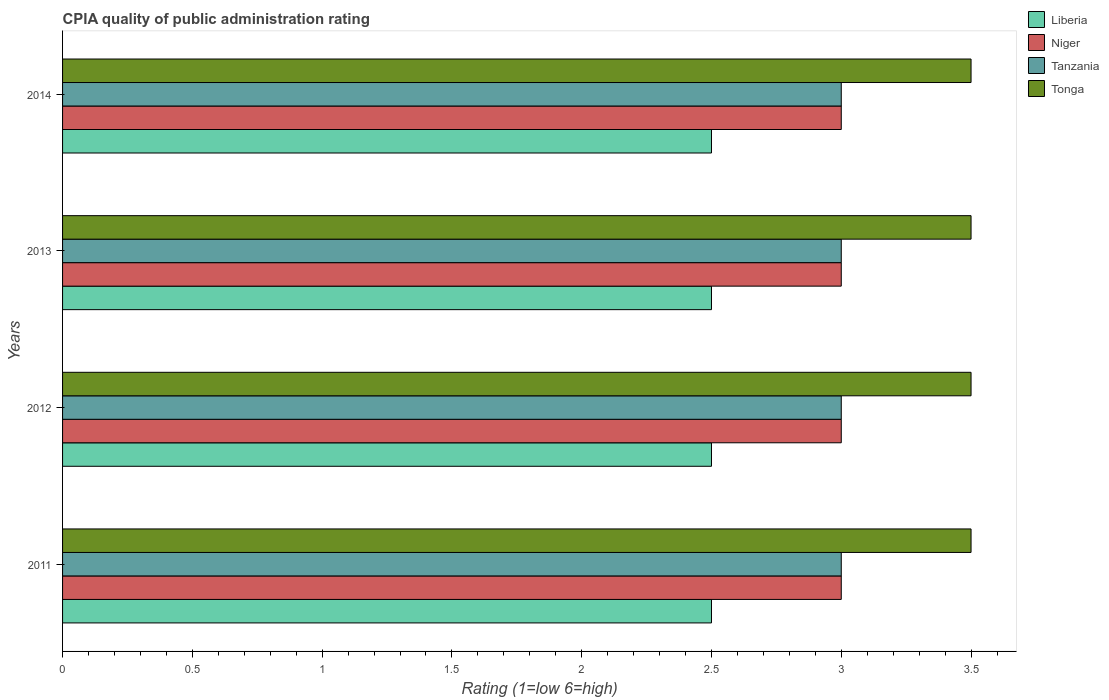Are the number of bars per tick equal to the number of legend labels?
Your answer should be compact. Yes. Are the number of bars on each tick of the Y-axis equal?
Ensure brevity in your answer.  Yes. How many bars are there on the 2nd tick from the bottom?
Ensure brevity in your answer.  4. What is the label of the 4th group of bars from the top?
Make the answer very short. 2011. In how many cases, is the number of bars for a given year not equal to the number of legend labels?
Your answer should be compact. 0. What is the CPIA rating in Niger in 2013?
Make the answer very short. 3. Across all years, what is the maximum CPIA rating in Niger?
Give a very brief answer. 3. Across all years, what is the minimum CPIA rating in Niger?
Ensure brevity in your answer.  3. In which year was the CPIA rating in Tonga maximum?
Keep it short and to the point. 2011. What is the total CPIA rating in Tonga in the graph?
Ensure brevity in your answer.  14. What is the difference between the CPIA rating in Tonga in 2011 and that in 2013?
Offer a terse response. 0. In the year 2013, what is the difference between the CPIA rating in Niger and CPIA rating in Liberia?
Give a very brief answer. 0.5. In how many years, is the CPIA rating in Liberia greater than 1.6 ?
Provide a short and direct response. 4. Is the difference between the CPIA rating in Niger in 2011 and 2014 greater than the difference between the CPIA rating in Liberia in 2011 and 2014?
Make the answer very short. No. What is the difference between the highest and the second highest CPIA rating in Tanzania?
Your response must be concise. 0. In how many years, is the CPIA rating in Niger greater than the average CPIA rating in Niger taken over all years?
Give a very brief answer. 0. Is the sum of the CPIA rating in Tanzania in 2011 and 2014 greater than the maximum CPIA rating in Tonga across all years?
Offer a very short reply. Yes. Is it the case that in every year, the sum of the CPIA rating in Liberia and CPIA rating in Tanzania is greater than the sum of CPIA rating in Tonga and CPIA rating in Niger?
Make the answer very short. Yes. What does the 2nd bar from the top in 2014 represents?
Your answer should be compact. Tanzania. What does the 2nd bar from the bottom in 2012 represents?
Keep it short and to the point. Niger. How many years are there in the graph?
Your answer should be compact. 4. What is the difference between two consecutive major ticks on the X-axis?
Ensure brevity in your answer.  0.5. What is the title of the graph?
Make the answer very short. CPIA quality of public administration rating. Does "Chile" appear as one of the legend labels in the graph?
Provide a succinct answer. No. What is the label or title of the X-axis?
Your response must be concise. Rating (1=low 6=high). What is the label or title of the Y-axis?
Your answer should be compact. Years. What is the Rating (1=low 6=high) of Liberia in 2011?
Ensure brevity in your answer.  2.5. What is the Rating (1=low 6=high) of Tanzania in 2011?
Your answer should be compact. 3. What is the Rating (1=low 6=high) of Tonga in 2011?
Give a very brief answer. 3.5. What is the Rating (1=low 6=high) in Liberia in 2012?
Give a very brief answer. 2.5. What is the Rating (1=low 6=high) in Niger in 2012?
Your response must be concise. 3. What is the Rating (1=low 6=high) in Niger in 2013?
Offer a very short reply. 3. What is the Rating (1=low 6=high) in Tonga in 2013?
Your answer should be very brief. 3.5. What is the Rating (1=low 6=high) in Liberia in 2014?
Give a very brief answer. 2.5. What is the Rating (1=low 6=high) in Tonga in 2014?
Provide a short and direct response. 3.5. Across all years, what is the maximum Rating (1=low 6=high) in Tanzania?
Provide a short and direct response. 3. Across all years, what is the minimum Rating (1=low 6=high) in Liberia?
Your answer should be very brief. 2.5. Across all years, what is the minimum Rating (1=low 6=high) in Tanzania?
Your answer should be compact. 3. What is the total Rating (1=low 6=high) of Liberia in the graph?
Provide a succinct answer. 10. What is the total Rating (1=low 6=high) of Tanzania in the graph?
Keep it short and to the point. 12. What is the difference between the Rating (1=low 6=high) in Liberia in 2011 and that in 2012?
Provide a succinct answer. 0. What is the difference between the Rating (1=low 6=high) of Tanzania in 2011 and that in 2012?
Give a very brief answer. 0. What is the difference between the Rating (1=low 6=high) in Tonga in 2011 and that in 2012?
Provide a short and direct response. 0. What is the difference between the Rating (1=low 6=high) in Niger in 2011 and that in 2013?
Give a very brief answer. 0. What is the difference between the Rating (1=low 6=high) of Tanzania in 2011 and that in 2013?
Your answer should be very brief. 0. What is the difference between the Rating (1=low 6=high) of Liberia in 2011 and that in 2014?
Provide a short and direct response. 0. What is the difference between the Rating (1=low 6=high) in Niger in 2011 and that in 2014?
Provide a short and direct response. 0. What is the difference between the Rating (1=low 6=high) in Tonga in 2011 and that in 2014?
Keep it short and to the point. 0. What is the difference between the Rating (1=low 6=high) in Tanzania in 2012 and that in 2013?
Provide a succinct answer. 0. What is the difference between the Rating (1=low 6=high) of Tonga in 2012 and that in 2013?
Offer a terse response. 0. What is the difference between the Rating (1=low 6=high) of Liberia in 2012 and that in 2014?
Offer a very short reply. 0. What is the difference between the Rating (1=low 6=high) of Tanzania in 2012 and that in 2014?
Provide a succinct answer. 0. What is the difference between the Rating (1=low 6=high) in Tonga in 2012 and that in 2014?
Give a very brief answer. 0. What is the difference between the Rating (1=low 6=high) in Liberia in 2013 and that in 2014?
Offer a terse response. 0. What is the difference between the Rating (1=low 6=high) in Niger in 2013 and that in 2014?
Your answer should be very brief. 0. What is the difference between the Rating (1=low 6=high) of Liberia in 2011 and the Rating (1=low 6=high) of Tanzania in 2012?
Provide a short and direct response. -0.5. What is the difference between the Rating (1=low 6=high) of Liberia in 2011 and the Rating (1=low 6=high) of Tonga in 2012?
Your answer should be very brief. -1. What is the difference between the Rating (1=low 6=high) in Tanzania in 2011 and the Rating (1=low 6=high) in Tonga in 2012?
Offer a terse response. -0.5. What is the difference between the Rating (1=low 6=high) of Liberia in 2011 and the Rating (1=low 6=high) of Tanzania in 2013?
Offer a terse response. -0.5. What is the difference between the Rating (1=low 6=high) of Liberia in 2011 and the Rating (1=low 6=high) of Tonga in 2013?
Your answer should be compact. -1. What is the difference between the Rating (1=low 6=high) in Niger in 2011 and the Rating (1=low 6=high) in Tanzania in 2013?
Your answer should be very brief. 0. What is the difference between the Rating (1=low 6=high) in Tanzania in 2011 and the Rating (1=low 6=high) in Tonga in 2013?
Provide a short and direct response. -0.5. What is the difference between the Rating (1=low 6=high) of Liberia in 2011 and the Rating (1=low 6=high) of Niger in 2014?
Keep it short and to the point. -0.5. What is the difference between the Rating (1=low 6=high) in Liberia in 2011 and the Rating (1=low 6=high) in Tanzania in 2014?
Your answer should be very brief. -0.5. What is the difference between the Rating (1=low 6=high) in Niger in 2011 and the Rating (1=low 6=high) in Tanzania in 2014?
Make the answer very short. 0. What is the difference between the Rating (1=low 6=high) of Tanzania in 2011 and the Rating (1=low 6=high) of Tonga in 2014?
Your answer should be compact. -0.5. What is the difference between the Rating (1=low 6=high) in Liberia in 2012 and the Rating (1=low 6=high) in Niger in 2013?
Your answer should be very brief. -0.5. What is the difference between the Rating (1=low 6=high) in Niger in 2012 and the Rating (1=low 6=high) in Tanzania in 2013?
Provide a succinct answer. 0. What is the difference between the Rating (1=low 6=high) of Niger in 2012 and the Rating (1=low 6=high) of Tonga in 2013?
Your answer should be compact. -0.5. What is the difference between the Rating (1=low 6=high) of Liberia in 2012 and the Rating (1=low 6=high) of Niger in 2014?
Your response must be concise. -0.5. What is the difference between the Rating (1=low 6=high) in Liberia in 2012 and the Rating (1=low 6=high) in Tanzania in 2014?
Offer a terse response. -0.5. What is the difference between the Rating (1=low 6=high) in Liberia in 2012 and the Rating (1=low 6=high) in Tonga in 2014?
Offer a very short reply. -1. What is the difference between the Rating (1=low 6=high) in Liberia in 2013 and the Rating (1=low 6=high) in Tonga in 2014?
Provide a succinct answer. -1. What is the difference between the Rating (1=low 6=high) in Niger in 2013 and the Rating (1=low 6=high) in Tonga in 2014?
Provide a succinct answer. -0.5. What is the difference between the Rating (1=low 6=high) of Tanzania in 2013 and the Rating (1=low 6=high) of Tonga in 2014?
Your response must be concise. -0.5. What is the average Rating (1=low 6=high) of Niger per year?
Offer a terse response. 3. What is the average Rating (1=low 6=high) of Tonga per year?
Offer a very short reply. 3.5. In the year 2011, what is the difference between the Rating (1=low 6=high) of Liberia and Rating (1=low 6=high) of Niger?
Give a very brief answer. -0.5. In the year 2011, what is the difference between the Rating (1=low 6=high) in Liberia and Rating (1=low 6=high) in Tanzania?
Make the answer very short. -0.5. In the year 2011, what is the difference between the Rating (1=low 6=high) in Liberia and Rating (1=low 6=high) in Tonga?
Offer a terse response. -1. In the year 2011, what is the difference between the Rating (1=low 6=high) of Niger and Rating (1=low 6=high) of Tonga?
Your answer should be compact. -0.5. In the year 2012, what is the difference between the Rating (1=low 6=high) in Liberia and Rating (1=low 6=high) in Tanzania?
Offer a very short reply. -0.5. In the year 2013, what is the difference between the Rating (1=low 6=high) of Liberia and Rating (1=low 6=high) of Tanzania?
Make the answer very short. -0.5. In the year 2013, what is the difference between the Rating (1=low 6=high) in Liberia and Rating (1=low 6=high) in Tonga?
Give a very brief answer. -1. In the year 2013, what is the difference between the Rating (1=low 6=high) in Tanzania and Rating (1=low 6=high) in Tonga?
Offer a terse response. -0.5. In the year 2014, what is the difference between the Rating (1=low 6=high) in Liberia and Rating (1=low 6=high) in Niger?
Ensure brevity in your answer.  -0.5. In the year 2014, what is the difference between the Rating (1=low 6=high) in Liberia and Rating (1=low 6=high) in Tanzania?
Make the answer very short. -0.5. In the year 2014, what is the difference between the Rating (1=low 6=high) of Liberia and Rating (1=low 6=high) of Tonga?
Provide a succinct answer. -1. In the year 2014, what is the difference between the Rating (1=low 6=high) in Niger and Rating (1=low 6=high) in Tonga?
Keep it short and to the point. -0.5. What is the ratio of the Rating (1=low 6=high) of Niger in 2011 to that in 2012?
Provide a succinct answer. 1. What is the ratio of the Rating (1=low 6=high) of Tanzania in 2011 to that in 2012?
Make the answer very short. 1. What is the ratio of the Rating (1=low 6=high) of Liberia in 2011 to that in 2013?
Your response must be concise. 1. What is the ratio of the Rating (1=low 6=high) of Niger in 2011 to that in 2013?
Your answer should be compact. 1. What is the ratio of the Rating (1=low 6=high) of Tanzania in 2011 to that in 2013?
Ensure brevity in your answer.  1. What is the ratio of the Rating (1=low 6=high) in Tonga in 2011 to that in 2013?
Offer a terse response. 1. What is the ratio of the Rating (1=low 6=high) of Liberia in 2011 to that in 2014?
Offer a very short reply. 1. What is the ratio of the Rating (1=low 6=high) in Niger in 2011 to that in 2014?
Ensure brevity in your answer.  1. What is the ratio of the Rating (1=low 6=high) of Tanzania in 2011 to that in 2014?
Offer a very short reply. 1. What is the ratio of the Rating (1=low 6=high) in Liberia in 2012 to that in 2013?
Offer a very short reply. 1. What is the ratio of the Rating (1=low 6=high) in Tanzania in 2012 to that in 2013?
Provide a succinct answer. 1. What is the ratio of the Rating (1=low 6=high) of Liberia in 2012 to that in 2014?
Your response must be concise. 1. What is the ratio of the Rating (1=low 6=high) of Niger in 2012 to that in 2014?
Ensure brevity in your answer.  1. What is the ratio of the Rating (1=low 6=high) in Tonga in 2012 to that in 2014?
Offer a terse response. 1. What is the ratio of the Rating (1=low 6=high) in Liberia in 2013 to that in 2014?
Provide a succinct answer. 1. What is the ratio of the Rating (1=low 6=high) in Tanzania in 2013 to that in 2014?
Ensure brevity in your answer.  1. What is the ratio of the Rating (1=low 6=high) in Tonga in 2013 to that in 2014?
Your answer should be compact. 1. What is the difference between the highest and the second highest Rating (1=low 6=high) of Liberia?
Provide a short and direct response. 0. What is the difference between the highest and the second highest Rating (1=low 6=high) of Tonga?
Make the answer very short. 0. What is the difference between the highest and the lowest Rating (1=low 6=high) of Niger?
Your response must be concise. 0. What is the difference between the highest and the lowest Rating (1=low 6=high) of Tonga?
Give a very brief answer. 0. 